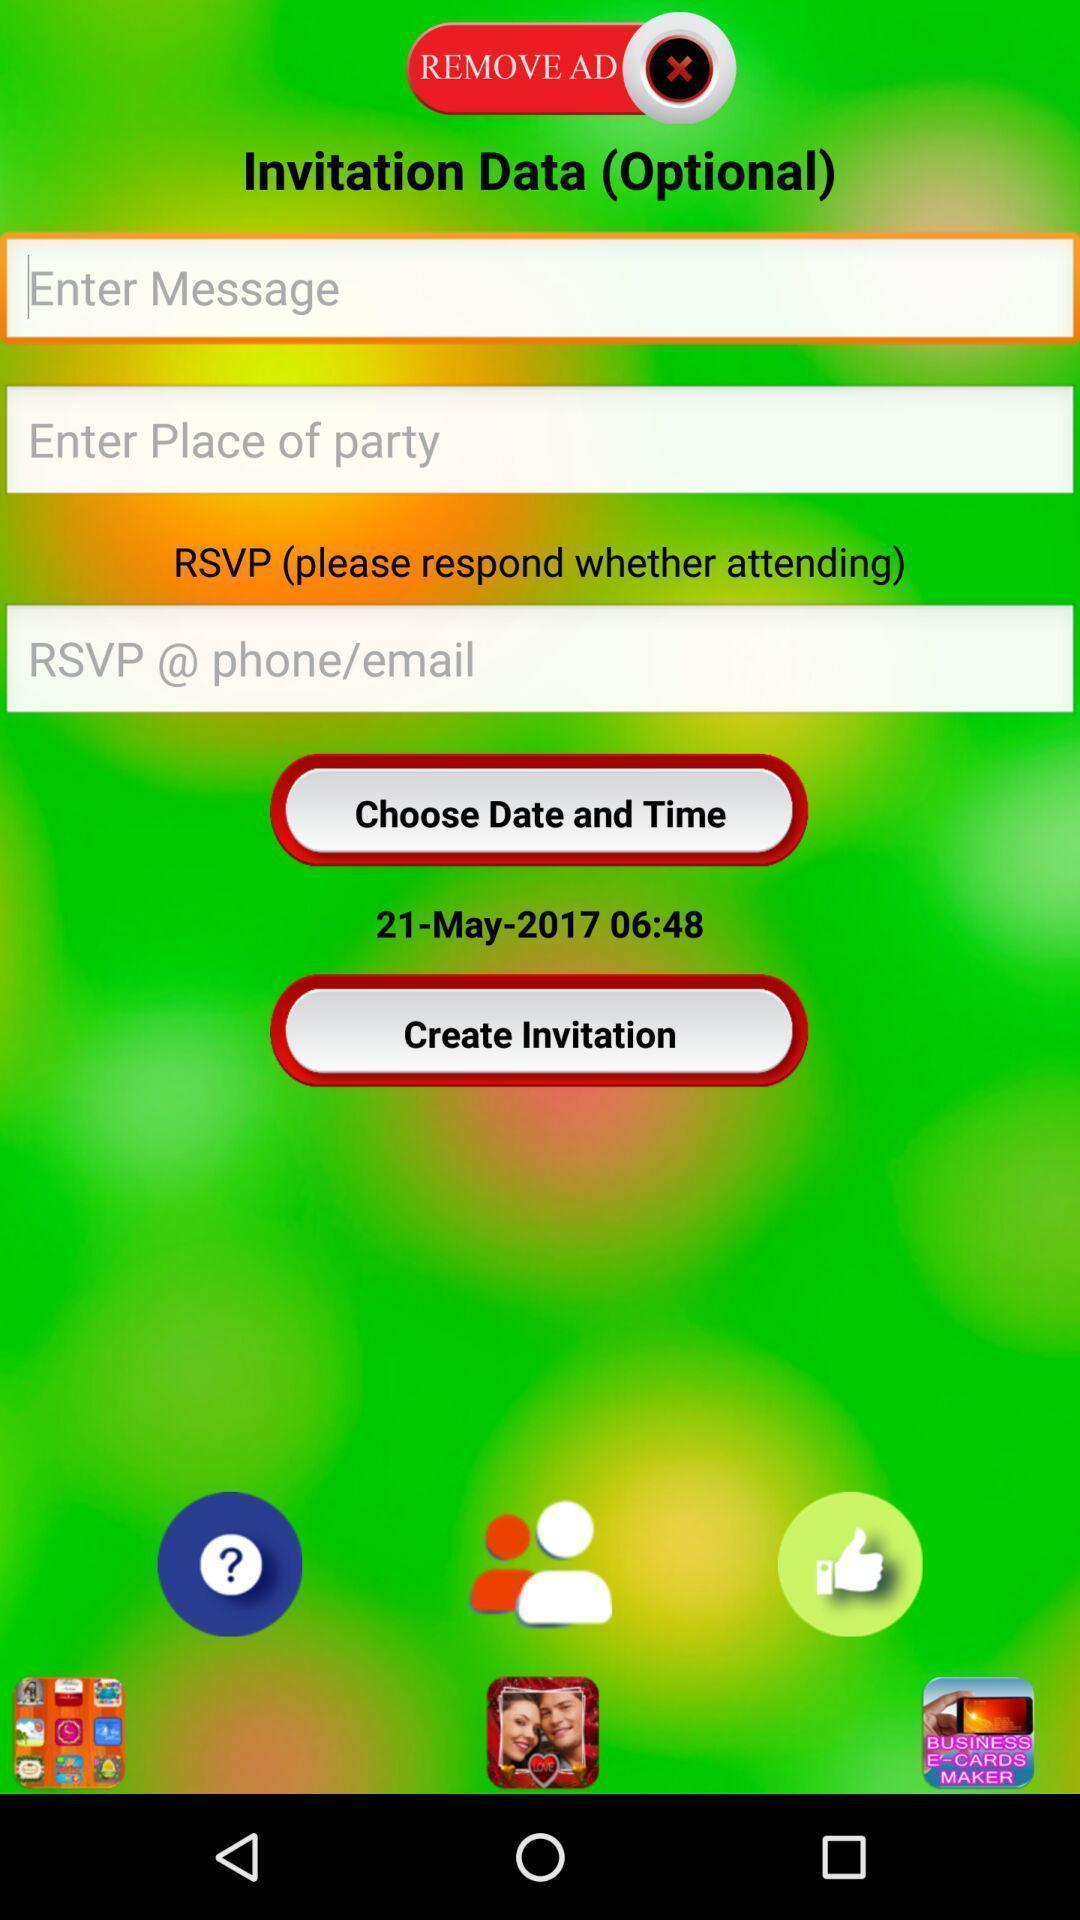Summarize the information in this screenshot. Screen displaying invitation page. 